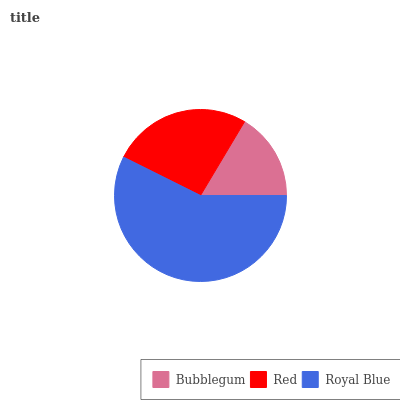Is Bubblegum the minimum?
Answer yes or no. Yes. Is Royal Blue the maximum?
Answer yes or no. Yes. Is Red the minimum?
Answer yes or no. No. Is Red the maximum?
Answer yes or no. No. Is Red greater than Bubblegum?
Answer yes or no. Yes. Is Bubblegum less than Red?
Answer yes or no. Yes. Is Bubblegum greater than Red?
Answer yes or no. No. Is Red less than Bubblegum?
Answer yes or no. No. Is Red the high median?
Answer yes or no. Yes. Is Red the low median?
Answer yes or no. Yes. Is Royal Blue the high median?
Answer yes or no. No. Is Bubblegum the low median?
Answer yes or no. No. 